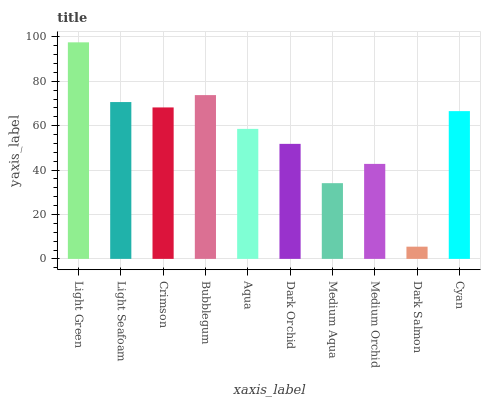Is Dark Salmon the minimum?
Answer yes or no. Yes. Is Light Green the maximum?
Answer yes or no. Yes. Is Light Seafoam the minimum?
Answer yes or no. No. Is Light Seafoam the maximum?
Answer yes or no. No. Is Light Green greater than Light Seafoam?
Answer yes or no. Yes. Is Light Seafoam less than Light Green?
Answer yes or no. Yes. Is Light Seafoam greater than Light Green?
Answer yes or no. No. Is Light Green less than Light Seafoam?
Answer yes or no. No. Is Cyan the high median?
Answer yes or no. Yes. Is Aqua the low median?
Answer yes or no. Yes. Is Dark Salmon the high median?
Answer yes or no. No. Is Dark Salmon the low median?
Answer yes or no. No. 